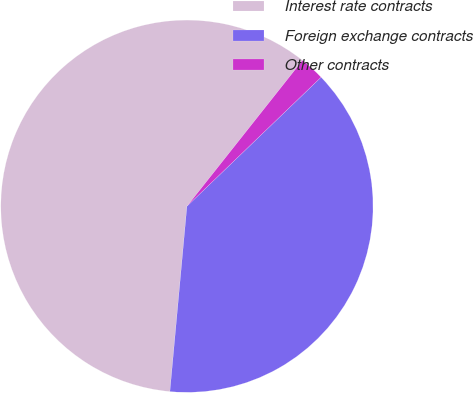Convert chart. <chart><loc_0><loc_0><loc_500><loc_500><pie_chart><fcel>Interest rate contracts<fcel>Foreign exchange contracts<fcel>Other contracts<nl><fcel>59.2%<fcel>38.65%<fcel>2.15%<nl></chart> 